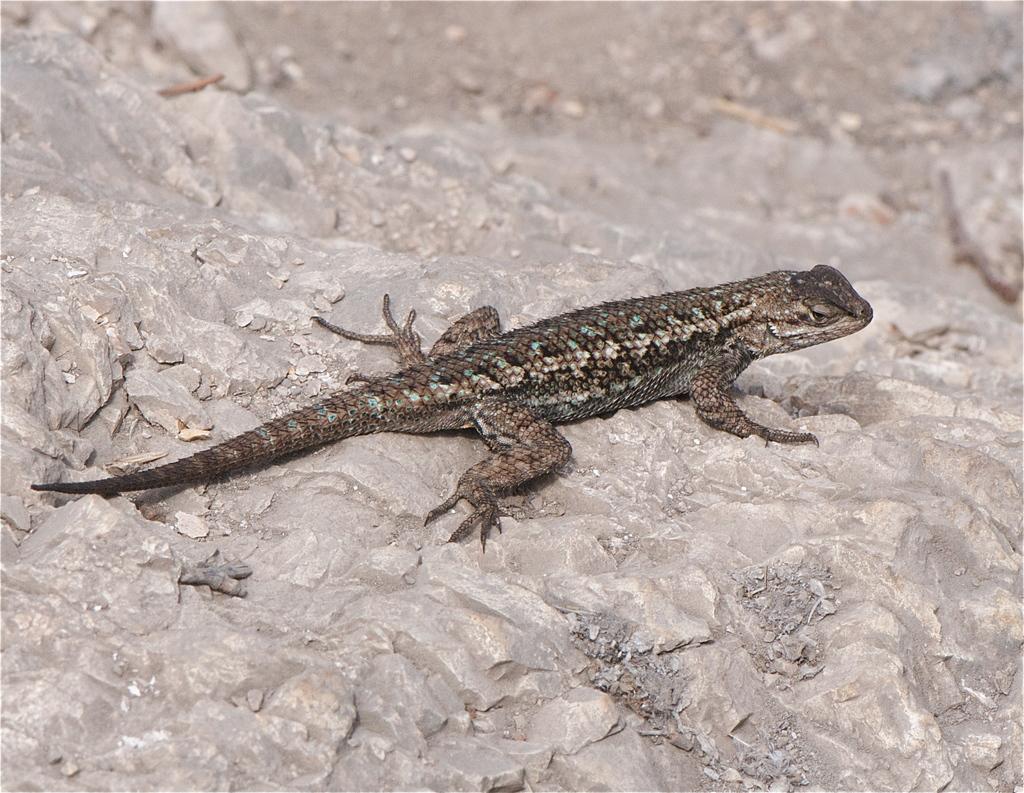Can you describe this image briefly? In this image I can see a reptile on the rock and it is facing towards the right side. 